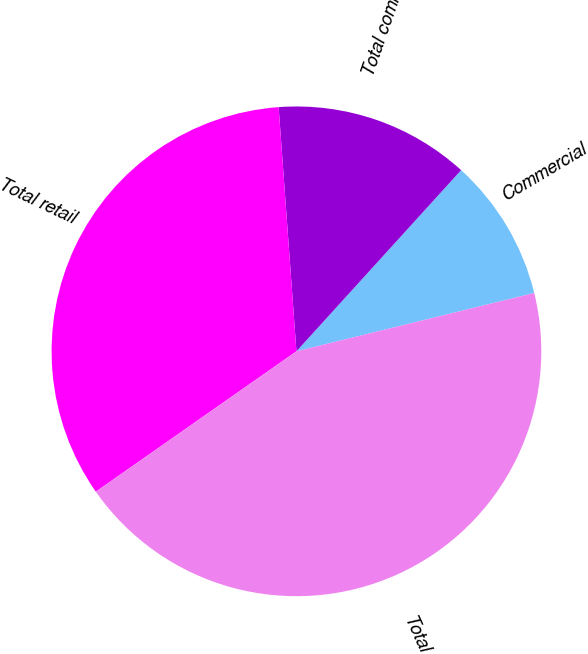Convert chart to OTSL. <chart><loc_0><loc_0><loc_500><loc_500><pie_chart><fcel>Commercial<fcel>Total commercial<fcel>Total retail<fcel>Total<nl><fcel>9.43%<fcel>12.9%<fcel>33.56%<fcel>44.11%<nl></chart> 